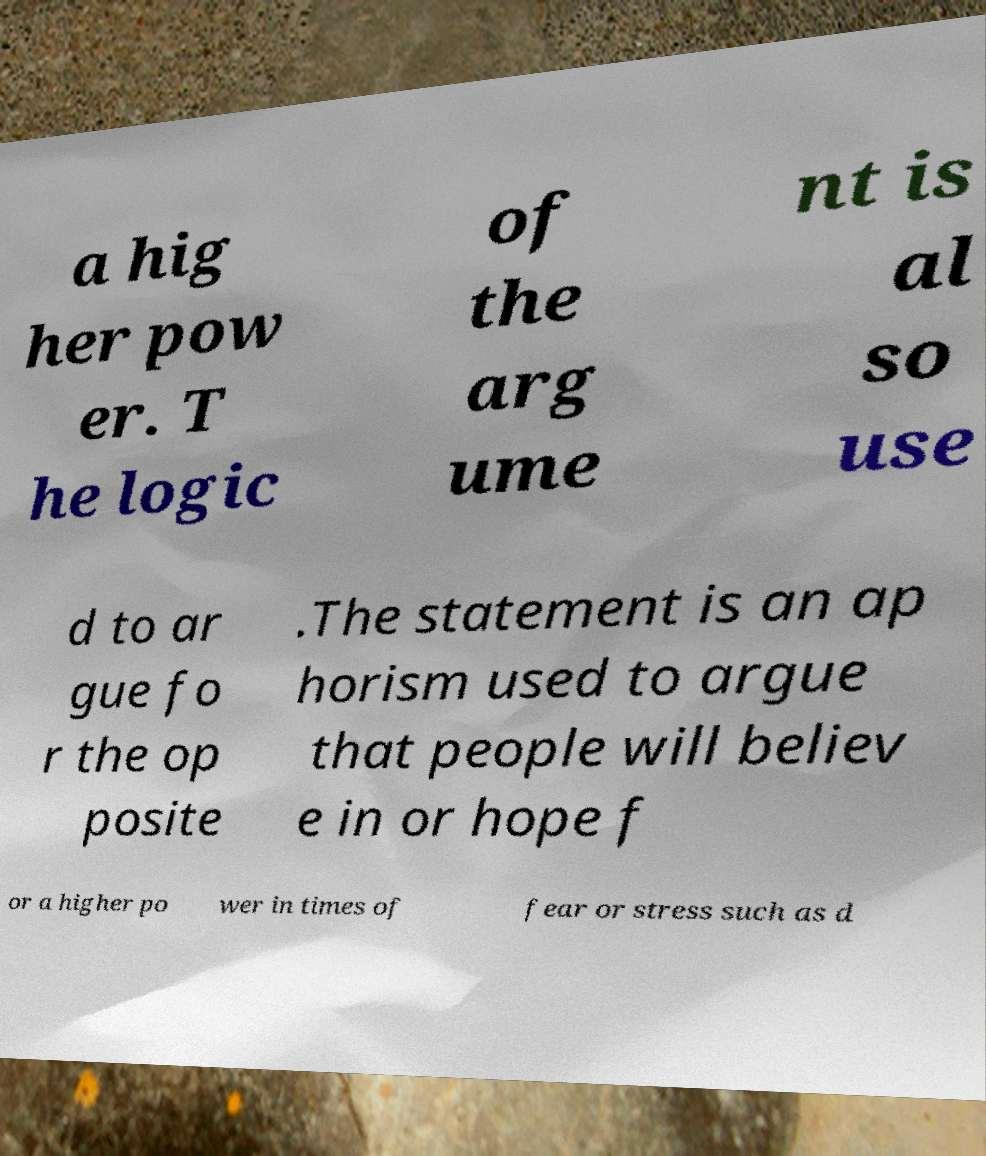Can you read and provide the text displayed in the image?This photo seems to have some interesting text. Can you extract and type it out for me? a hig her pow er. T he logic of the arg ume nt is al so use d to ar gue fo r the op posite .The statement is an ap horism used to argue that people will believ e in or hope f or a higher po wer in times of fear or stress such as d 